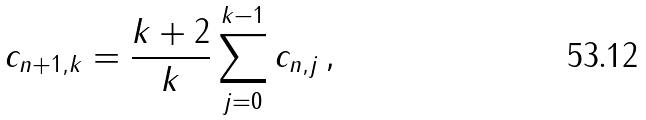Convert formula to latex. <formula><loc_0><loc_0><loc_500><loc_500>c _ { n + 1 , k } = \frac { k + 2 } { k } \sum _ { j = 0 } ^ { k - 1 } c _ { n , j } \, ,</formula> 